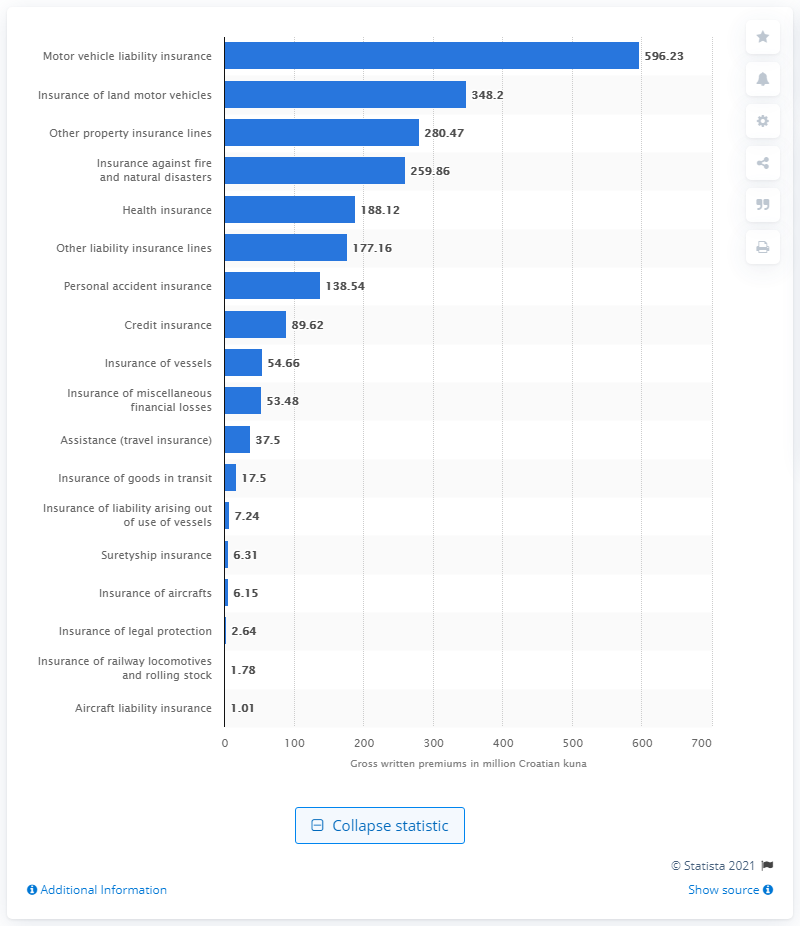Mention a couple of crucial points in this snapshot. In the first quarter of 2020, land motor vehicles comprised 348.2 tons of Croatian kuna. In the first quarter of 2020, the total amount of Croatian kuna that motor vehicle liability insurance gross written premiums amounted to was 596.23. 